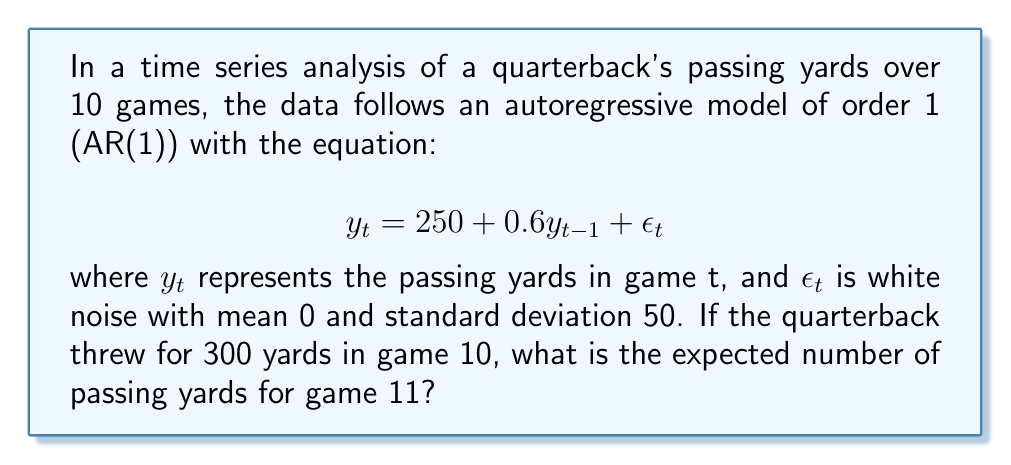Help me with this question. To solve this problem, we'll follow these steps:

1) The AR(1) model is given by:
   $$y_t = 250 + 0.6y_{t-1} + \epsilon_t$$

2) We're asked to predict $y_{11}$ given $y_{10} = 300$.

3) The expected value of $y_{11}$ is:
   $$E[y_{11}] = 250 + 0.6E[y_{10}] + E[\epsilon_{11}]$$

4) We know that:
   - $y_{10} = 300$
   - $E[\epsilon_{11}] = 0$ (as $\epsilon_t$ is white noise with mean 0)

5) Substituting these values:
   $$E[y_{11}] = 250 + 0.6(300) + 0$$

6) Calculate:
   $$E[y_{11}] = 250 + 180 = 430$$

Therefore, the expected number of passing yards for game 11 is 430 yards.
Answer: 430 yards 